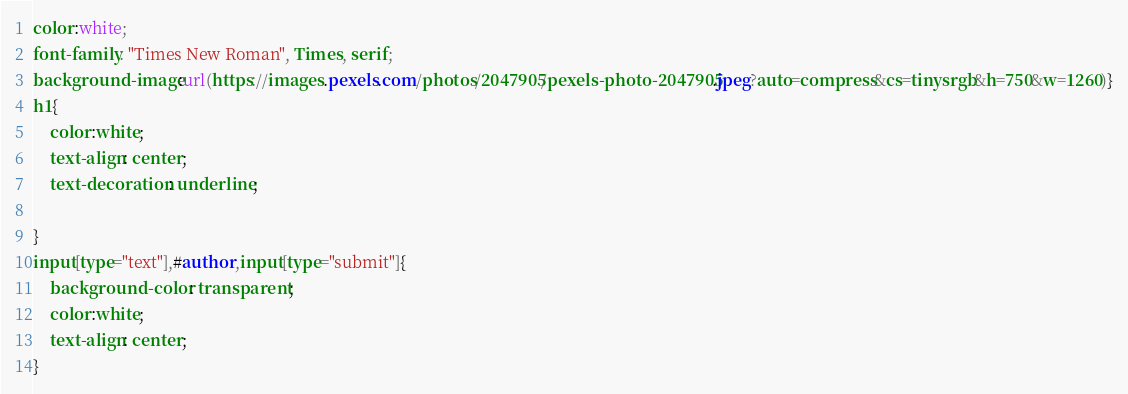<code> <loc_0><loc_0><loc_500><loc_500><_CSS_>
color:white;
font-family: "Times New Roman", Times, serif;
background-image:url(https://images.pexels.com/photos/2047905/pexels-photo-2047905.jpeg?auto=compress&cs=tinysrgb&h=750&w=1260)}
h1{
    color:white;
    text-align: center;
    text-decoration: underline;
    
}
input[type="text"],#author,input[type="submit"]{
    background-color: transparent;
    color:white;
    text-align: center;
}


</code> 